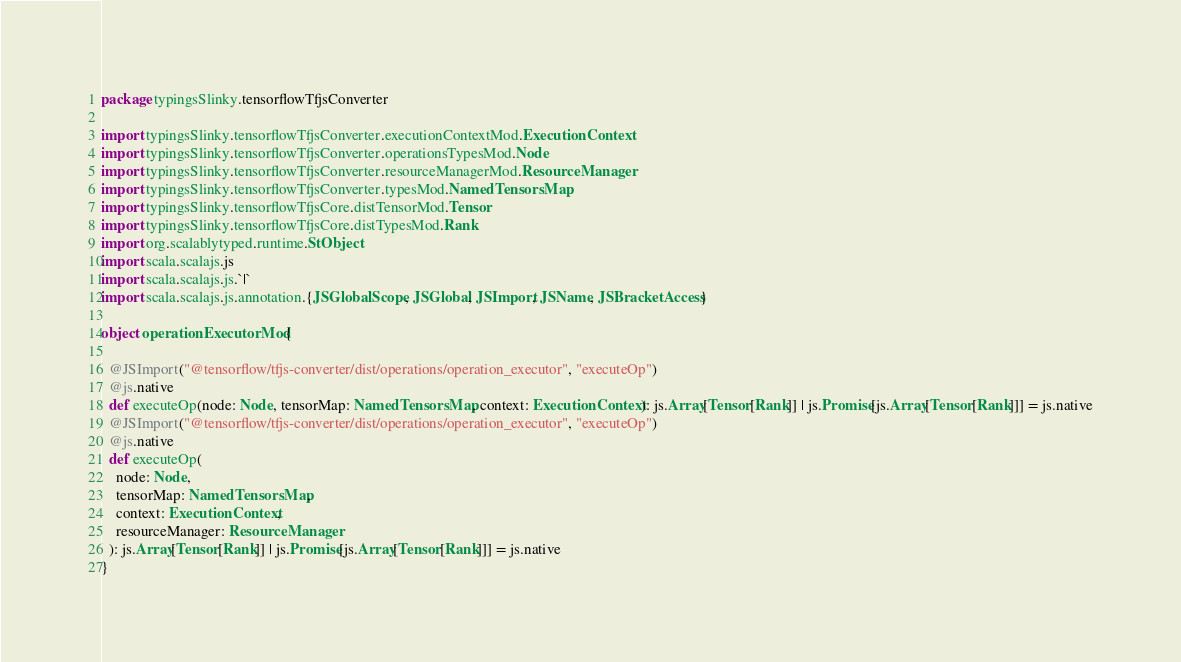<code> <loc_0><loc_0><loc_500><loc_500><_Scala_>package typingsSlinky.tensorflowTfjsConverter

import typingsSlinky.tensorflowTfjsConverter.executionContextMod.ExecutionContext
import typingsSlinky.tensorflowTfjsConverter.operationsTypesMod.Node
import typingsSlinky.tensorflowTfjsConverter.resourceManagerMod.ResourceManager
import typingsSlinky.tensorflowTfjsConverter.typesMod.NamedTensorsMap
import typingsSlinky.tensorflowTfjsCore.distTensorMod.Tensor
import typingsSlinky.tensorflowTfjsCore.distTypesMod.Rank
import org.scalablytyped.runtime.StObject
import scala.scalajs.js
import scala.scalajs.js.`|`
import scala.scalajs.js.annotation.{JSGlobalScope, JSGlobal, JSImport, JSName, JSBracketAccess}

object operationExecutorMod {
  
  @JSImport("@tensorflow/tfjs-converter/dist/operations/operation_executor", "executeOp")
  @js.native
  def executeOp(node: Node, tensorMap: NamedTensorsMap, context: ExecutionContext): js.Array[Tensor[Rank]] | js.Promise[js.Array[Tensor[Rank]]] = js.native
  @JSImport("@tensorflow/tfjs-converter/dist/operations/operation_executor", "executeOp")
  @js.native
  def executeOp(
    node: Node,
    tensorMap: NamedTensorsMap,
    context: ExecutionContext,
    resourceManager: ResourceManager
  ): js.Array[Tensor[Rank]] | js.Promise[js.Array[Tensor[Rank]]] = js.native
}
</code> 